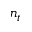<formula> <loc_0><loc_0><loc_500><loc_500>n _ { t }</formula> 